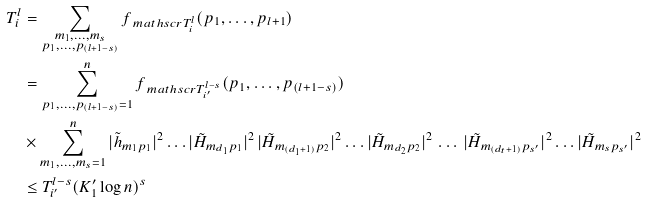<formula> <loc_0><loc_0><loc_500><loc_500>T _ { i } ^ { l } & = \sum _ { \substack { m _ { 1 } , \dots , m _ { s } \\ p _ { 1 } , \dots , p _ { ( l + 1 - s ) } } } f _ { \ m a t h s c r { T } _ { i } ^ { l } } ( p _ { 1 } , \dots , p _ { l + 1 } ) \\ & = \sum _ { p _ { 1 } , \dots , p _ { ( l + 1 - s ) } = 1 } ^ { n } f _ { \ m a t h s c r { T } _ { i ^ { \prime } } ^ { l - s } } ( p _ { 1 } , \dots , p _ { ( l + 1 - s ) } ) \\ & \times \sum _ { m _ { 1 } , \dots , m _ { s } = 1 } ^ { n } | \tilde { h } _ { m _ { 1 } p _ { 1 } } | ^ { 2 } \dots | \tilde { H } _ { m _ { d _ { 1 } } p _ { 1 } } | ^ { 2 } \, | \tilde { H } _ { m _ { ( d _ { 1 } + 1 ) } p _ { 2 } } | ^ { 2 } \dots | \tilde { H } _ { m _ { d _ { 2 } } p _ { 2 } } | ^ { 2 } \, \dots \, | \tilde { H } _ { m _ { ( d _ { t } + 1 ) } p _ { s ^ { \prime } } } | ^ { 2 } \dots | \tilde { H } _ { m _ { s } p _ { s ^ { \prime } } } | ^ { 2 } \\ & \leq T _ { i ^ { \prime } } ^ { l - s } ( K _ { 1 } ^ { \prime } \log n ) ^ { s }</formula> 